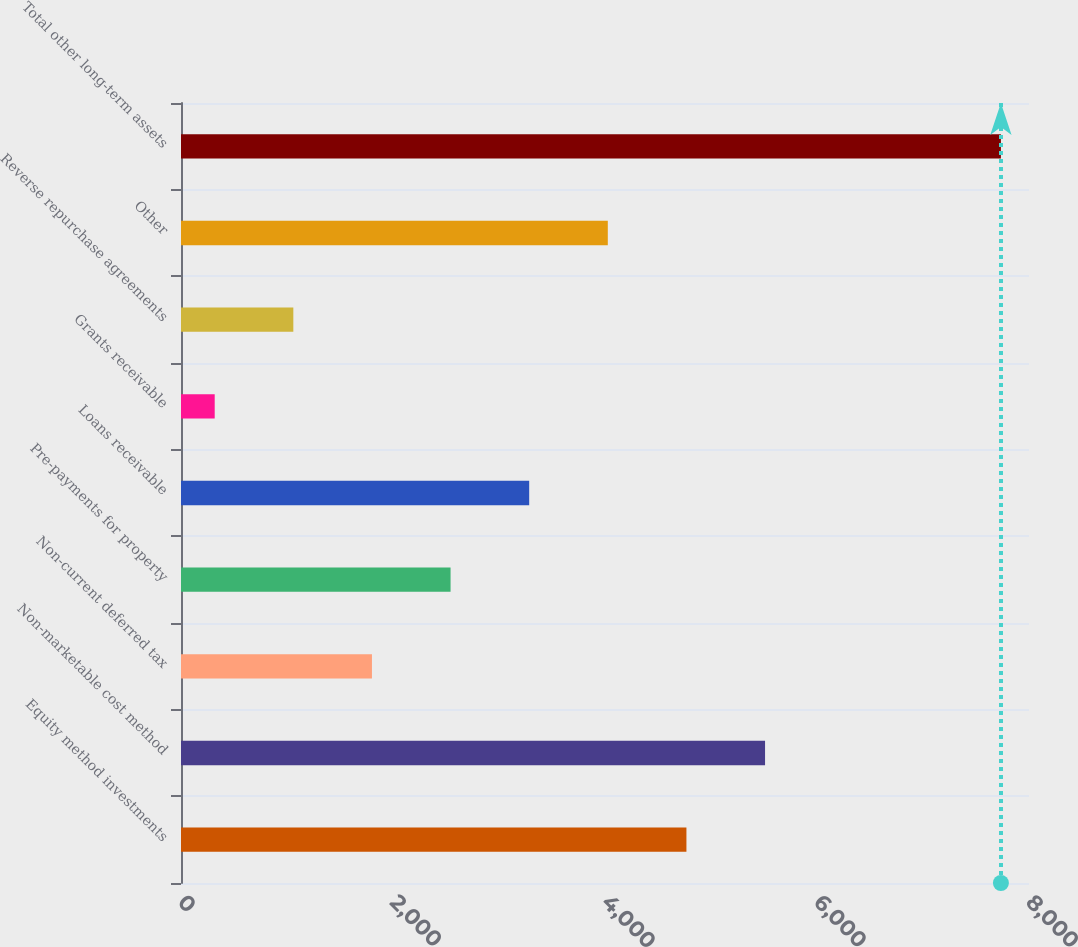<chart> <loc_0><loc_0><loc_500><loc_500><bar_chart><fcel>Equity method investments<fcel>Non-marketable cost method<fcel>Non-current deferred tax<fcel>Pre-payments for property<fcel>Loans receivable<fcel>Grants receivable<fcel>Reverse repurchase agreements<fcel>Other<fcel>Total other long-term assets<nl><fcel>4768.2<fcel>5509.9<fcel>1801.4<fcel>2543.1<fcel>3284.8<fcel>318<fcel>1059.7<fcel>4026.5<fcel>7735<nl></chart> 